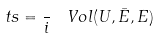<formula> <loc_0><loc_0><loc_500><loc_500>\ t s = \frac { } { i } \, \ V o l ( U , \bar { E } , E )</formula> 